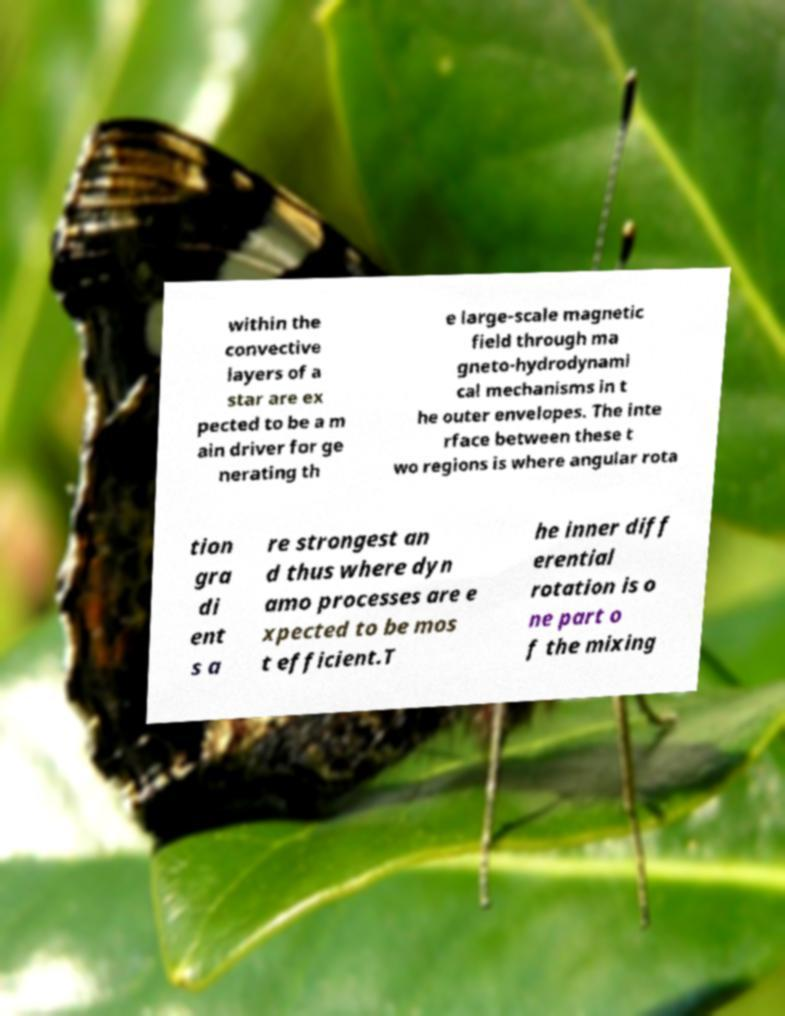For documentation purposes, I need the text within this image transcribed. Could you provide that? within the convective layers of a star are ex pected to be a m ain driver for ge nerating th e large-scale magnetic field through ma gneto-hydrodynami cal mechanisms in t he outer envelopes. The inte rface between these t wo regions is where angular rota tion gra di ent s a re strongest an d thus where dyn amo processes are e xpected to be mos t efficient.T he inner diff erential rotation is o ne part o f the mixing 